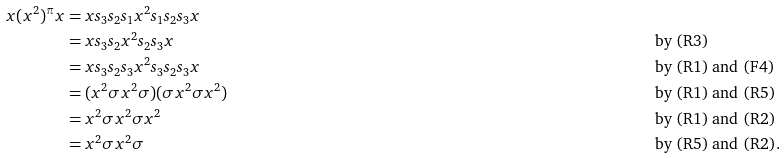<formula> <loc_0><loc_0><loc_500><loc_500>x ( x ^ { 2 } ) ^ { \pi } x & = x s _ { 3 } s _ { 2 } s _ { 1 } x ^ { 2 } s _ { 1 } s _ { 2 } s _ { 3 } x \\ & = x s _ { 3 } s _ { 2 } x ^ { 2 } s _ { 2 } s _ { 3 } x & & \text {by (R3)} \\ & = x s _ { 3 } s _ { 2 } s _ { 3 } x ^ { 2 } s _ { 3 } s _ { 2 } s _ { 3 } x & & \text {by (R1) and (F4)} \\ & = ( x ^ { 2 } \sigma x ^ { 2 } \sigma ) ( \sigma x ^ { 2 } \sigma x ^ { 2 } ) & & \text {by (R1) and (R5)} \\ & = x ^ { 2 } \sigma x ^ { 2 } \sigma x ^ { 2 } & & \text {by (R1) and (R2)} \\ & = x ^ { 2 } \sigma x ^ { 2 } \sigma & & \text {by (R5) and (R2).}</formula> 